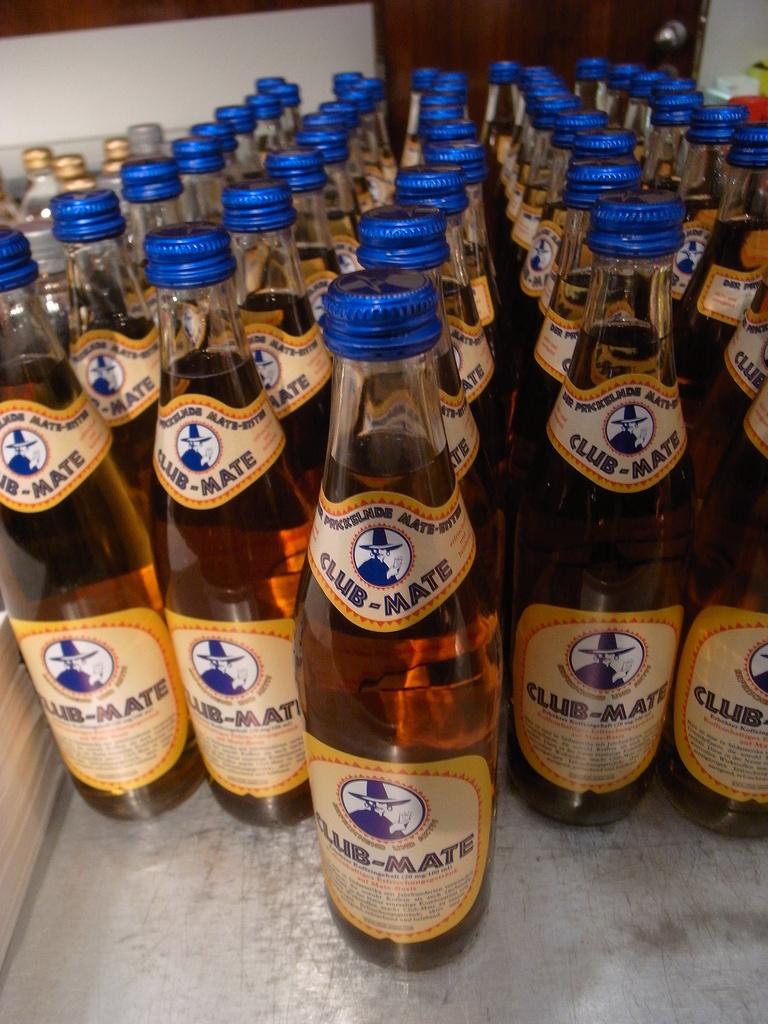What is the name of this drink?
Your answer should be very brief. Club-mate. What color are the lids?
Give a very brief answer. Answering does not require reading text in the image. 